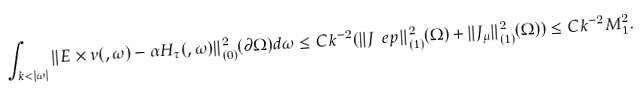Convert formula to latex. <formula><loc_0><loc_0><loc_500><loc_500>\int _ { k < | \omega | } \| E \times \nu ( , \omega ) - \alpha H _ { \tau } ( , \omega ) \| ^ { 2 } _ { ( 0 ) } ( \partial \Omega ) d \omega \leq C k ^ { - 2 } ( \| J _ { \ } e p \| ^ { 2 } _ { ( 1 ) } ( \Omega ) + \| J _ { \mu } \| ^ { 2 } _ { ( 1 ) } ( \Omega ) ) \leq C k ^ { - 2 } M _ { 1 } ^ { 2 } .</formula> 